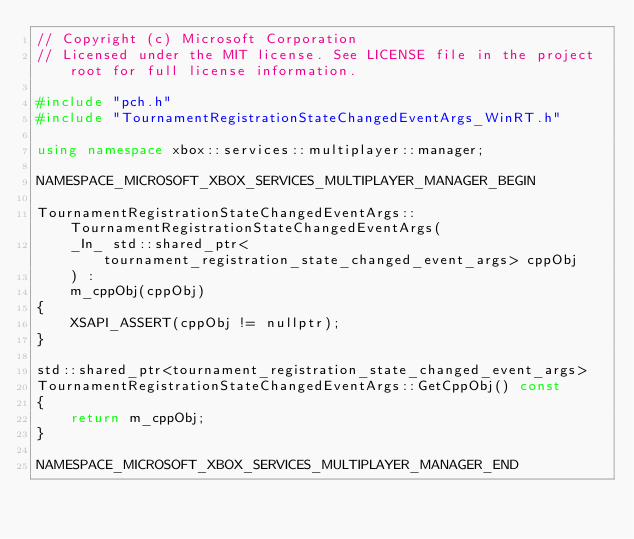Convert code to text. <code><loc_0><loc_0><loc_500><loc_500><_C++_>// Copyright (c) Microsoft Corporation
// Licensed under the MIT license. See LICENSE file in the project root for full license information.

#include "pch.h"
#include "TournamentRegistrationStateChangedEventArgs_WinRT.h"

using namespace xbox::services::multiplayer::manager;

NAMESPACE_MICROSOFT_XBOX_SERVICES_MULTIPLAYER_MANAGER_BEGIN

TournamentRegistrationStateChangedEventArgs::TournamentRegistrationStateChangedEventArgs(
    _In_ std::shared_ptr<tournament_registration_state_changed_event_args> cppObj
    ) :
    m_cppObj(cppObj)
{
    XSAPI_ASSERT(cppObj != nullptr);
}

std::shared_ptr<tournament_registration_state_changed_event_args>
TournamentRegistrationStateChangedEventArgs::GetCppObj() const
{
    return m_cppObj;
}

NAMESPACE_MICROSOFT_XBOX_SERVICES_MULTIPLAYER_MANAGER_END</code> 